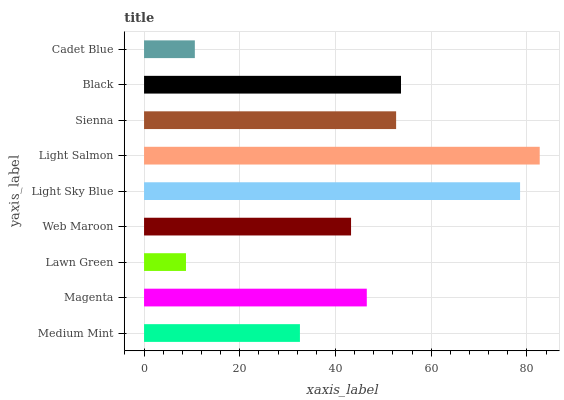Is Lawn Green the minimum?
Answer yes or no. Yes. Is Light Salmon the maximum?
Answer yes or no. Yes. Is Magenta the minimum?
Answer yes or no. No. Is Magenta the maximum?
Answer yes or no. No. Is Magenta greater than Medium Mint?
Answer yes or no. Yes. Is Medium Mint less than Magenta?
Answer yes or no. Yes. Is Medium Mint greater than Magenta?
Answer yes or no. No. Is Magenta less than Medium Mint?
Answer yes or no. No. Is Magenta the high median?
Answer yes or no. Yes. Is Magenta the low median?
Answer yes or no. Yes. Is Black the high median?
Answer yes or no. No. Is Black the low median?
Answer yes or no. No. 